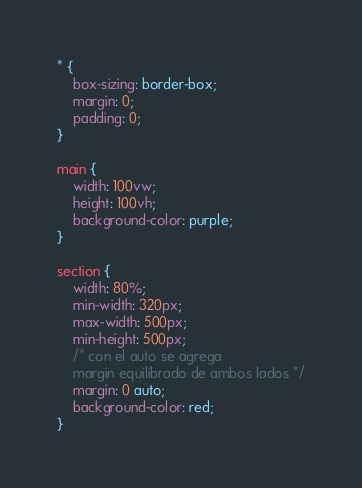<code> <loc_0><loc_0><loc_500><loc_500><_CSS_>* {
    box-sizing: border-box;
    margin: 0;
    padding: 0;
}

main {
    width: 100vw;
    height: 100vh;
    background-color: purple;
}

section {
    width: 80%;
    min-width: 320px;
    max-width: 500px;
    min-height: 500px;
    /* con el auto se agrega 
    margin equilibrado de ambos lados */
    margin: 0 auto;
    background-color: red;
}</code> 